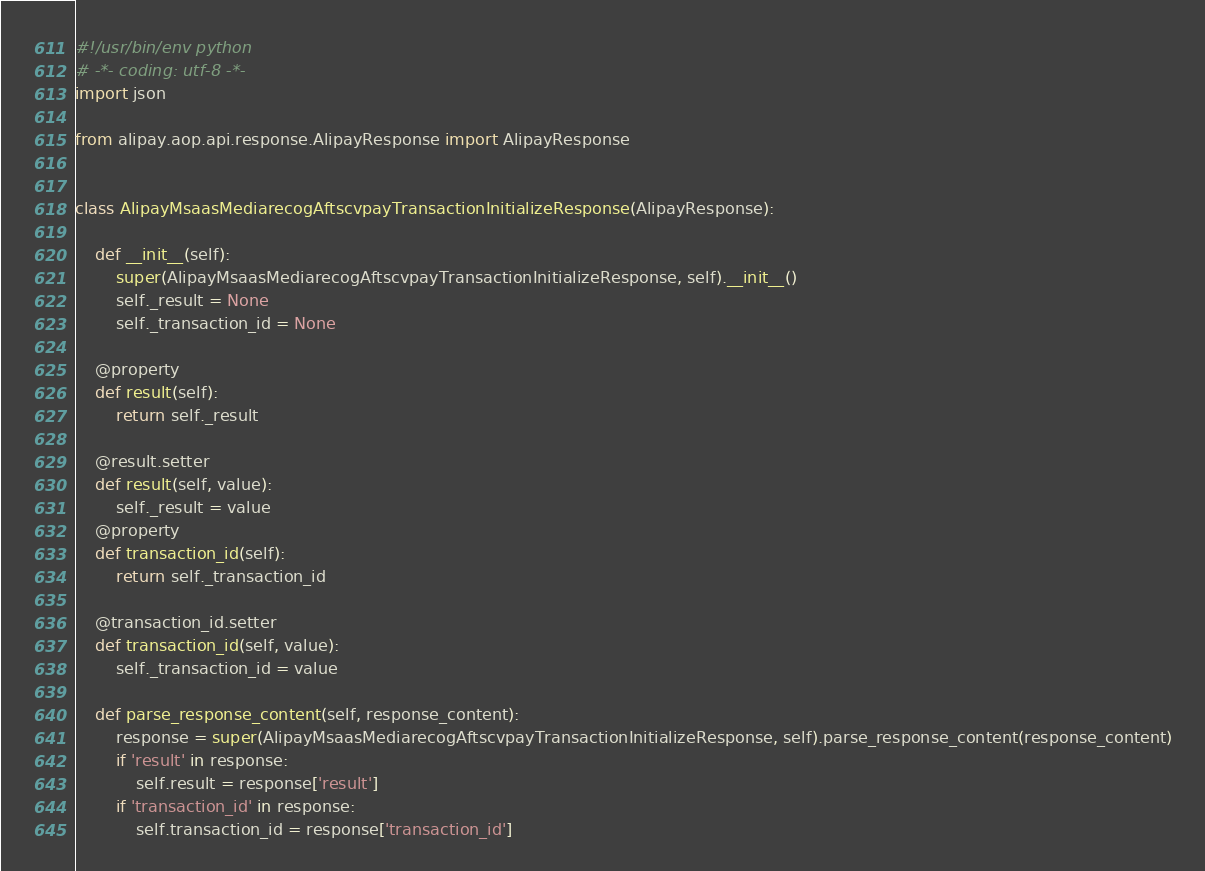Convert code to text. <code><loc_0><loc_0><loc_500><loc_500><_Python_>#!/usr/bin/env python
# -*- coding: utf-8 -*-
import json

from alipay.aop.api.response.AlipayResponse import AlipayResponse


class AlipayMsaasMediarecogAftscvpayTransactionInitializeResponse(AlipayResponse):

    def __init__(self):
        super(AlipayMsaasMediarecogAftscvpayTransactionInitializeResponse, self).__init__()
        self._result = None
        self._transaction_id = None

    @property
    def result(self):
        return self._result

    @result.setter
    def result(self, value):
        self._result = value
    @property
    def transaction_id(self):
        return self._transaction_id

    @transaction_id.setter
    def transaction_id(self, value):
        self._transaction_id = value

    def parse_response_content(self, response_content):
        response = super(AlipayMsaasMediarecogAftscvpayTransactionInitializeResponse, self).parse_response_content(response_content)
        if 'result' in response:
            self.result = response['result']
        if 'transaction_id' in response:
            self.transaction_id = response['transaction_id']
</code> 